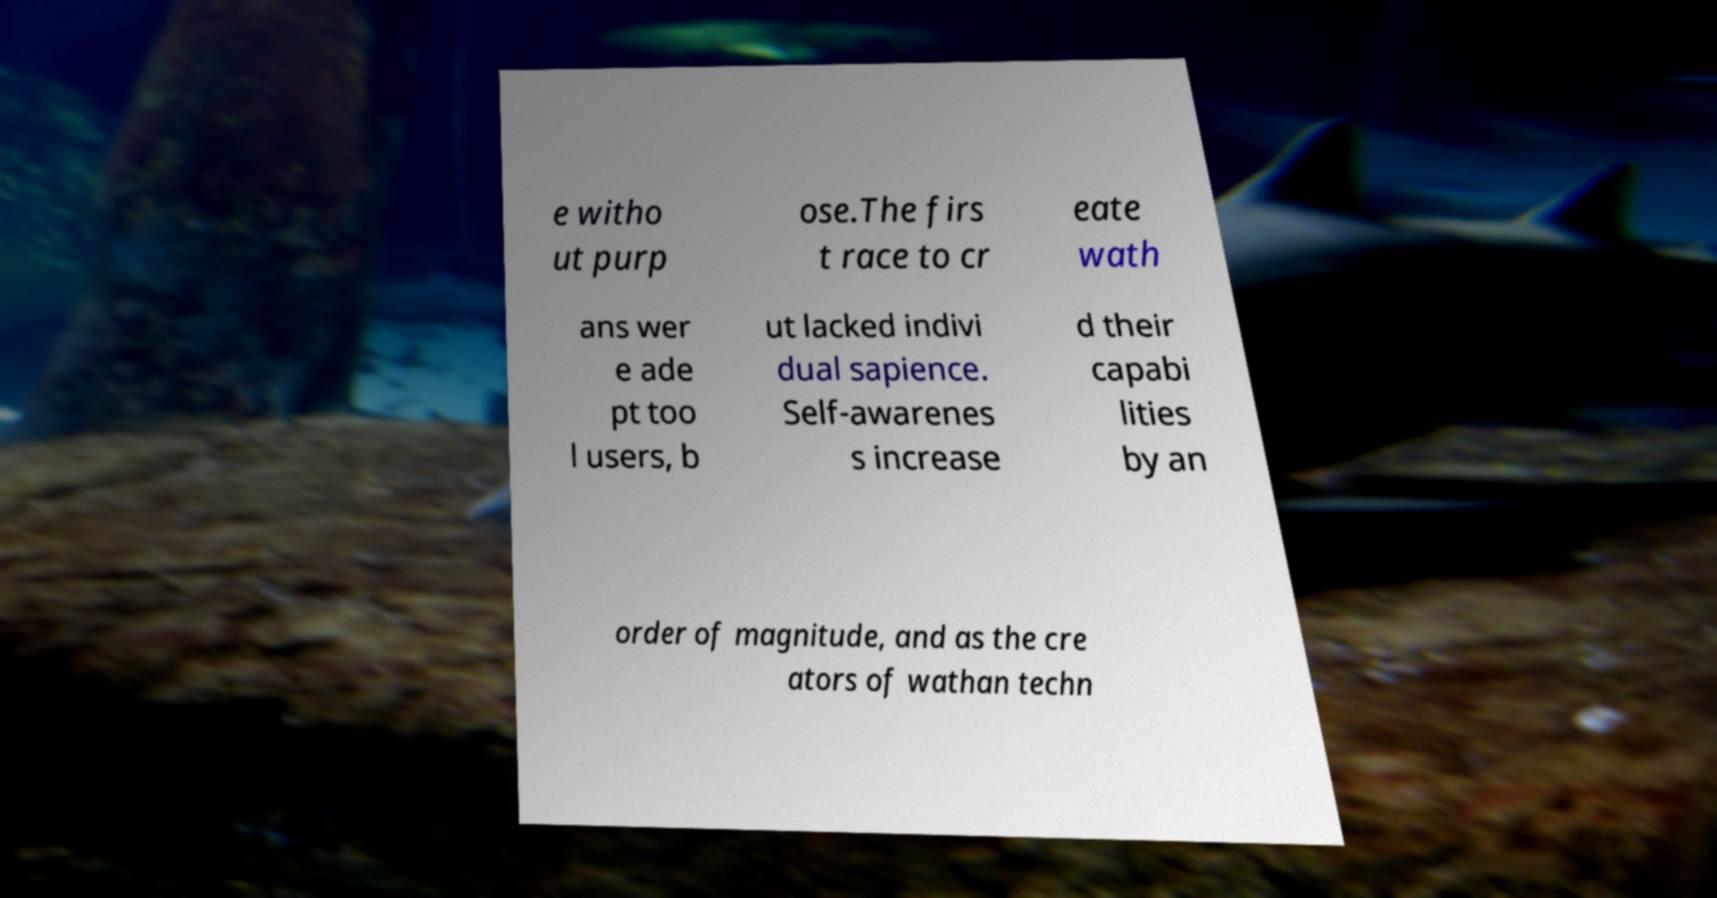What messages or text are displayed in this image? I need them in a readable, typed format. e witho ut purp ose.The firs t race to cr eate wath ans wer e ade pt too l users, b ut lacked indivi dual sapience. Self-awarenes s increase d their capabi lities by an order of magnitude, and as the cre ators of wathan techn 